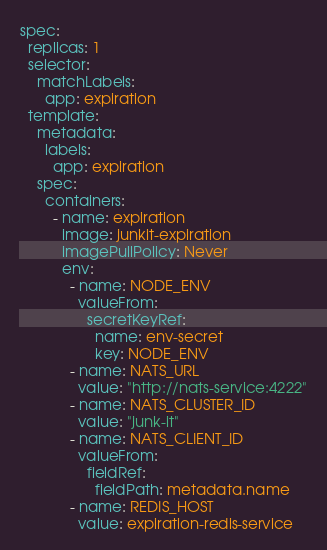Convert code to text. <code><loc_0><loc_0><loc_500><loc_500><_YAML_>spec:
  replicas: 1
  selector:
    matchLabels:
      app: expiration
  template:
    metadata:
      labels:
        app: expiration
    spec:
      containers:
        - name: expiration
          image: junkit-expiration
          imagePullPolicy: Never
          env:
            - name: NODE_ENV
              valueFrom:
                secretKeyRef:
                  name: env-secret
                  key: NODE_ENV
            - name: NATS_URL
              value: "http://nats-service:4222"
            - name: NATS_CLUSTER_ID
              value: "junk-it"
            - name: NATS_CLIENT_ID
              valueFrom:
                fieldRef:
                  fieldPath: metadata.name
            - name: REDIS_HOST
              value: expiration-redis-service
</code> 